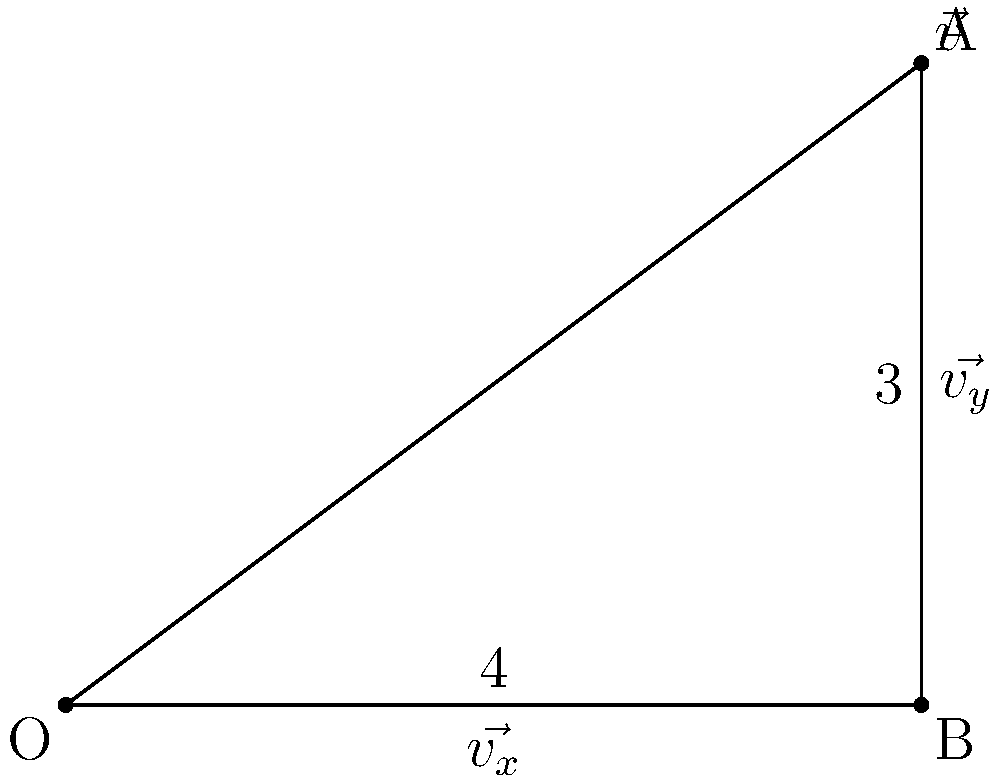In an urban green space study, a vector $\vec{v}$ represents the combined effect of tree density and plant diversity on local biodiversity. If $\vec{v}$ has a magnitude of 5 units and is decomposed into horizontal component $\vec{v_x}$ (representing tree density) and vertical component $\vec{v_y}$ (representing plant diversity) as shown in the figure, calculate the magnitude of $\vec{v_y}$. How does this component contribute to the overall biodiversity effect? To solve this problem, we'll follow these steps:

1) First, we recognize that the vector $\vec{v}$ forms a right triangle with its components $\vec{v_x}$ and $\vec{v_y}$.

2) We're given that the magnitude of $\vec{v}$ is 5 units, and from the figure, we can see that $\vec{v_x}$ has a magnitude of 4 units.

3) We can use the Pythagorean theorem to find the magnitude of $\vec{v_y}$:

   $$|\vec{v}|^2 = |\vec{v_x}|^2 + |\vec{v_y}|^2$$

4) Substituting the known values:

   $$5^2 = 4^2 + |\vec{v_y}|^2$$

5) Simplify:

   $$25 = 16 + |\vec{v_y}|^2$$

6) Solve for $|\vec{v_y}|$:

   $$|\vec{v_y}|^2 = 25 - 16 = 9$$
   $$|\vec{v_y}| = \sqrt{9} = 3$$

7) Therefore, the magnitude of $\vec{v_y}$ is 3 units.

8) In the context of the urban green space study, $\vec{v_y}$ represents the effect of plant diversity on local biodiversity. Its magnitude of 3 units suggests a significant contribution to the overall biodiversity effect, accounting for 60% of the total effect (3/5 = 0.6).
Answer: 3 units; significant contribution (60% of total effect) 